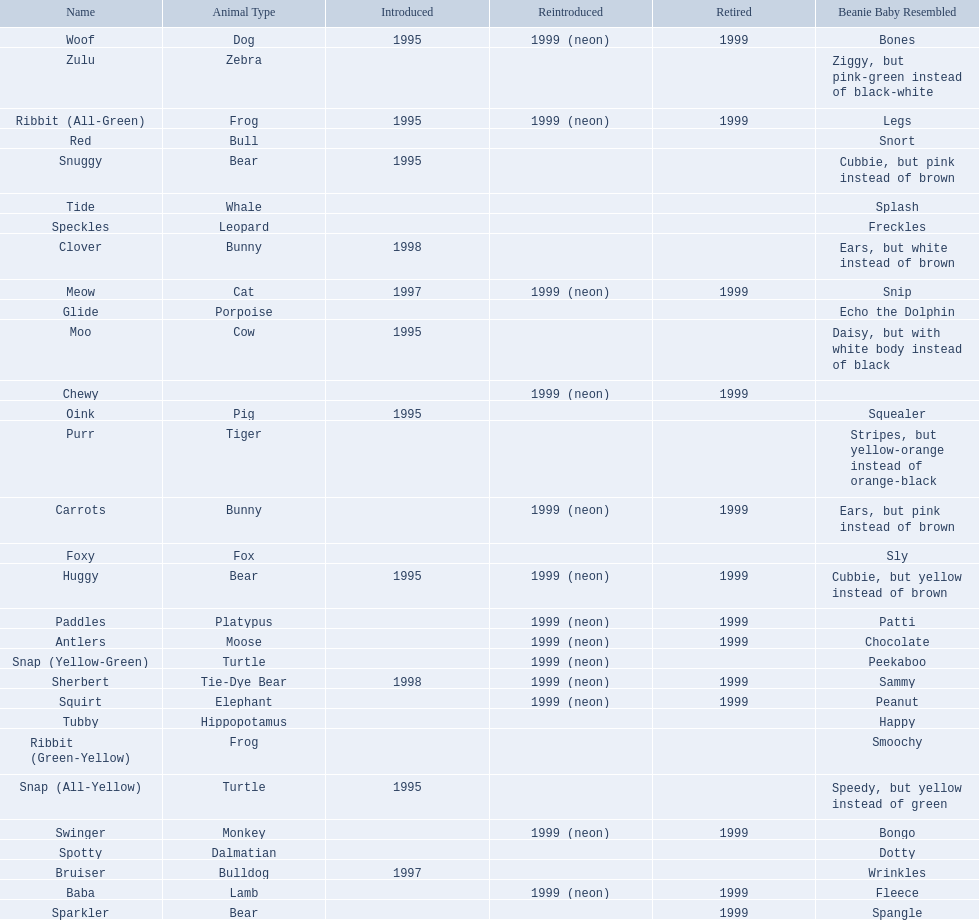What are all the different names of the pillow pals? Antlers, Baba, Bruiser, Carrots, Chewy, Clover, Foxy, Glide, Huggy, Meow, Moo, Oink, Paddles, Purr, Red, Ribbit (All-Green), Ribbit (Green-Yellow), Sherbert, Snap (All-Yellow), Snap (Yellow-Green), Snuggy, Sparkler, Speckles, Spotty, Squirt, Swinger, Tide, Tubby, Woof, Zulu. Which of these are a dalmatian? Spotty. 